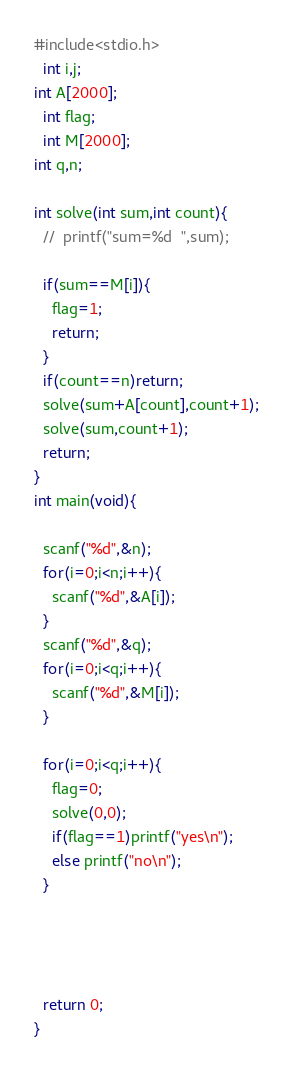<code> <loc_0><loc_0><loc_500><loc_500><_C_>#include<stdio.h>
  int i,j;
int A[2000];
  int flag;
  int M[2000];
int q,n;

int solve(int sum,int count){
  //  printf("sum=%d  ",sum);

  if(sum==M[i]){
    flag=1;
    return;
  }
  if(count==n)return;
  solve(sum+A[count],count+1);
  solve(sum,count+1);
  return;
}
int main(void){

  scanf("%d",&n);
  for(i=0;i<n;i++){
    scanf("%d",&A[i]);
  }
  scanf("%d",&q);
  for(i=0;i<q;i++){
    scanf("%d",&M[i]);
  }
 
  for(i=0;i<q;i++){
    flag=0;
    solve(0,0);   
    if(flag==1)printf("yes\n");
    else printf("no\n");
  }
   
   
 
 
  return 0;
}</code> 